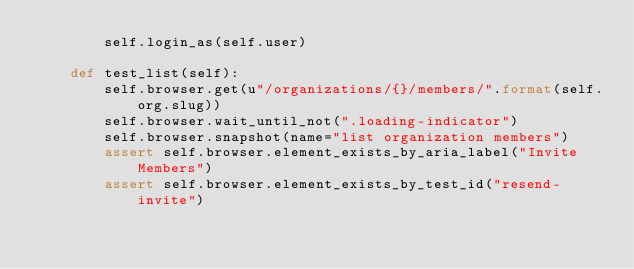<code> <loc_0><loc_0><loc_500><loc_500><_Python_>        self.login_as(self.user)

    def test_list(self):
        self.browser.get(u"/organizations/{}/members/".format(self.org.slug))
        self.browser.wait_until_not(".loading-indicator")
        self.browser.snapshot(name="list organization members")
        assert self.browser.element_exists_by_aria_label("Invite Members")
        assert self.browser.element_exists_by_test_id("resend-invite")
</code> 